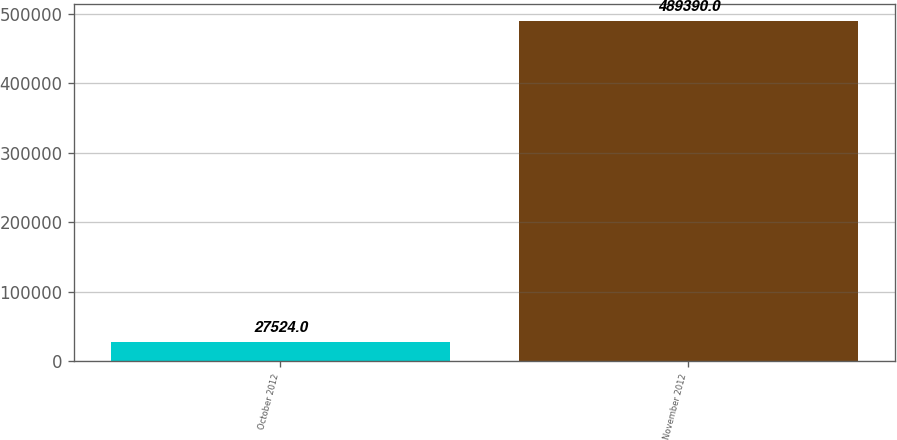Convert chart to OTSL. <chart><loc_0><loc_0><loc_500><loc_500><bar_chart><fcel>October 2012<fcel>November 2012<nl><fcel>27524<fcel>489390<nl></chart> 